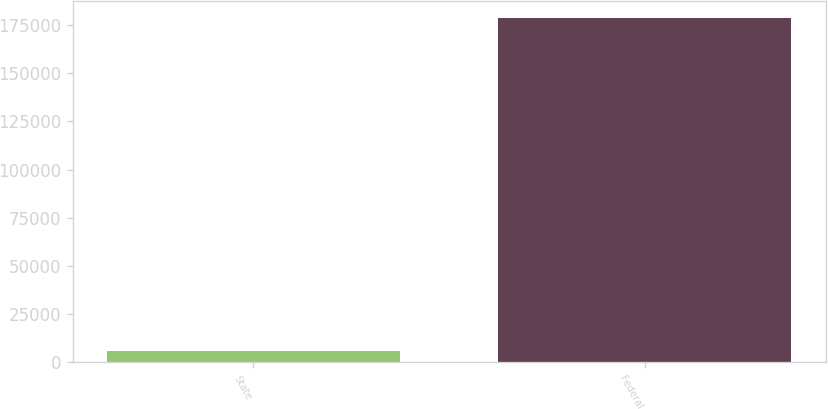<chart> <loc_0><loc_0><loc_500><loc_500><bar_chart><fcel>State<fcel>Federal<nl><fcel>5667<fcel>178630<nl></chart> 